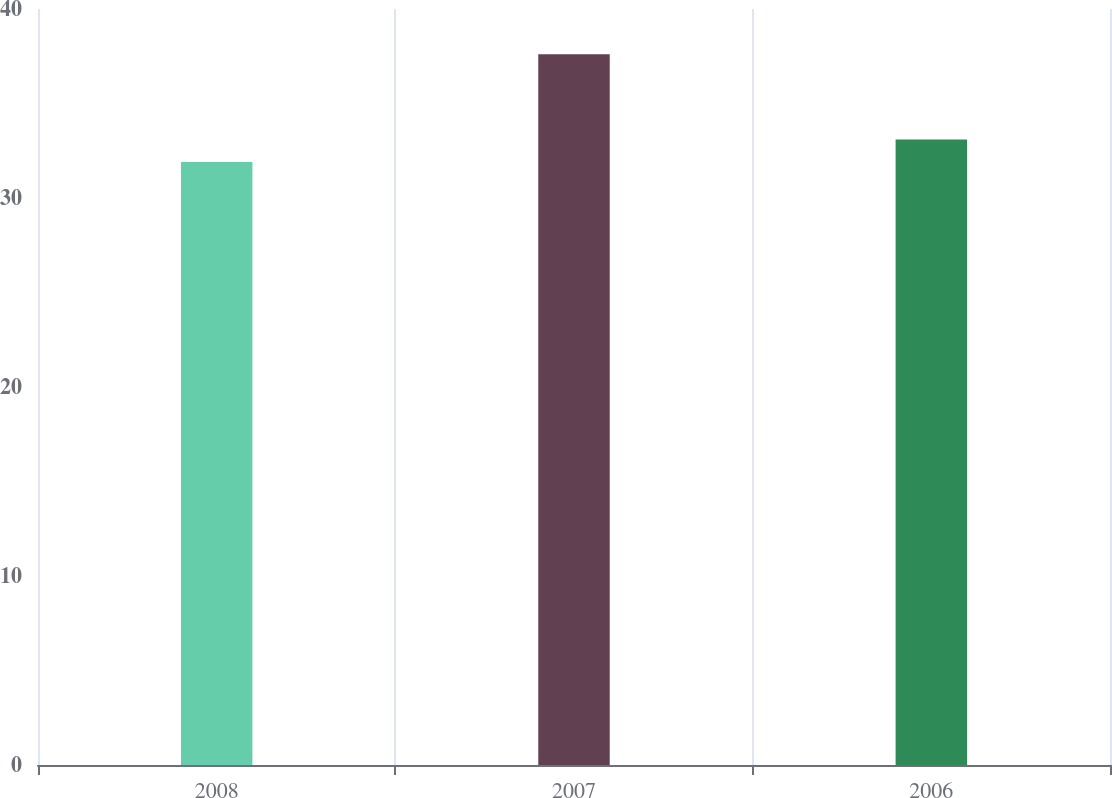Convert chart. <chart><loc_0><loc_0><loc_500><loc_500><bar_chart><fcel>2008<fcel>2007<fcel>2006<nl><fcel>31.9<fcel>37.6<fcel>33.1<nl></chart> 